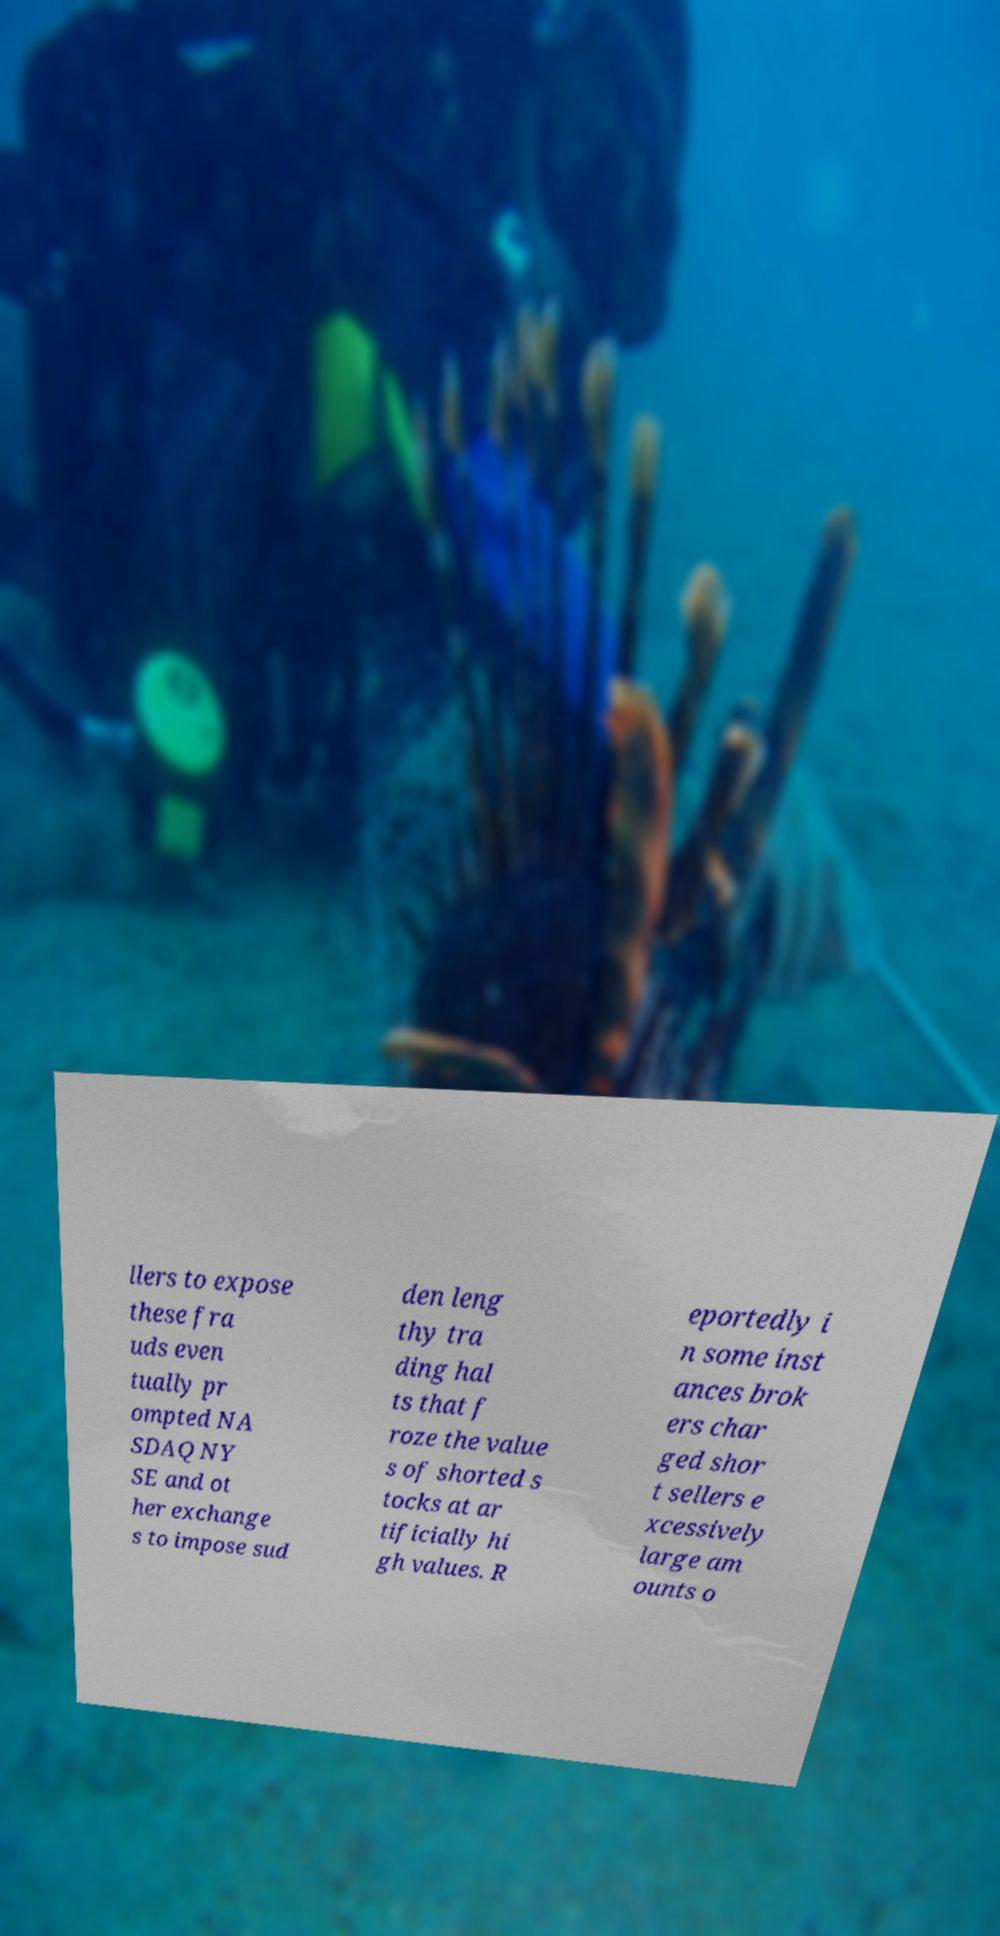What messages or text are displayed in this image? I need them in a readable, typed format. llers to expose these fra uds even tually pr ompted NA SDAQ NY SE and ot her exchange s to impose sud den leng thy tra ding hal ts that f roze the value s of shorted s tocks at ar tificially hi gh values. R eportedly i n some inst ances brok ers char ged shor t sellers e xcessively large am ounts o 